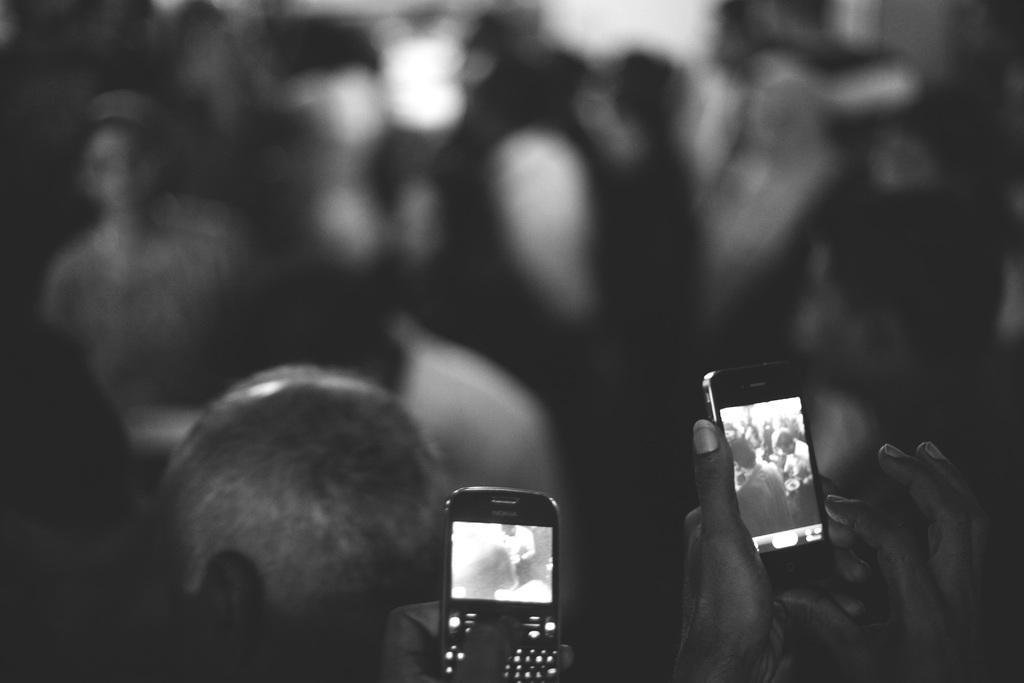Describe this image in one or two sentences. This image consists of two persons holding mobiles. In the background, we can many people. The background is blurred. 